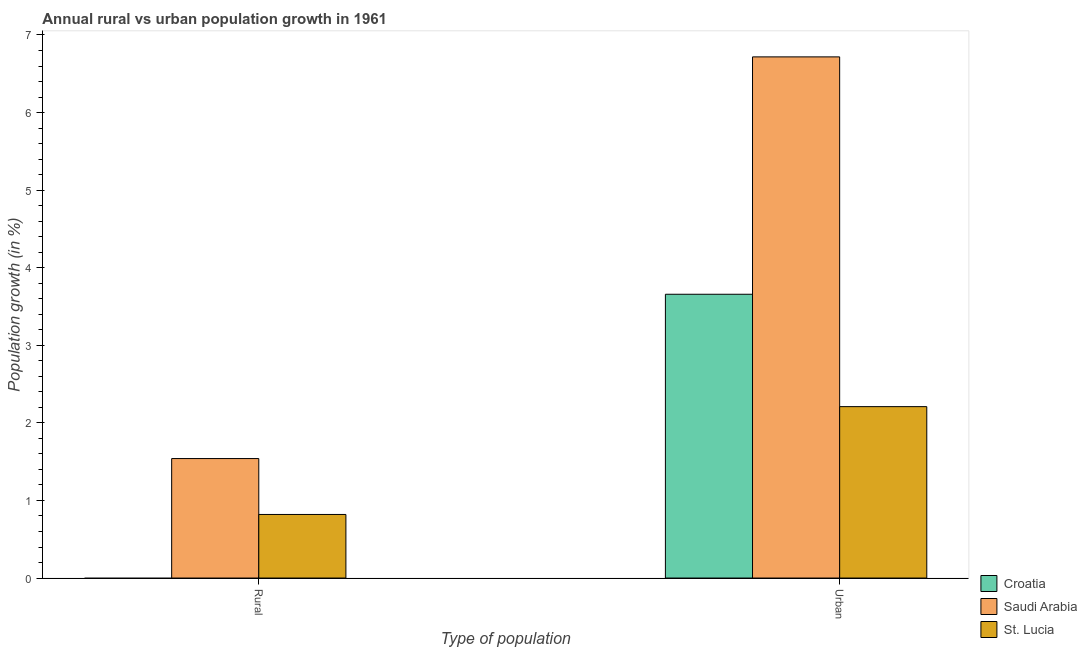How many different coloured bars are there?
Ensure brevity in your answer.  3. Are the number of bars per tick equal to the number of legend labels?
Offer a terse response. No. Are the number of bars on each tick of the X-axis equal?
Your response must be concise. No. What is the label of the 2nd group of bars from the left?
Your response must be concise. Urban . What is the rural population growth in Saudi Arabia?
Provide a succinct answer. 1.54. Across all countries, what is the maximum rural population growth?
Offer a very short reply. 1.54. Across all countries, what is the minimum urban population growth?
Keep it short and to the point. 2.21. In which country was the urban population growth maximum?
Offer a very short reply. Saudi Arabia. What is the total rural population growth in the graph?
Provide a short and direct response. 2.36. What is the difference between the urban population growth in Saudi Arabia and that in Croatia?
Keep it short and to the point. 3.06. What is the difference between the urban population growth in Croatia and the rural population growth in St. Lucia?
Make the answer very short. 2.84. What is the average urban population growth per country?
Offer a terse response. 4.2. What is the difference between the rural population growth and urban population growth in St. Lucia?
Provide a succinct answer. -1.39. What is the ratio of the urban population growth in St. Lucia to that in Croatia?
Your answer should be compact. 0.6. Is the urban population growth in Croatia less than that in St. Lucia?
Your answer should be compact. No. In how many countries, is the urban population growth greater than the average urban population growth taken over all countries?
Offer a very short reply. 1. How many countries are there in the graph?
Make the answer very short. 3. Does the graph contain any zero values?
Your response must be concise. Yes. Does the graph contain grids?
Your response must be concise. No. Where does the legend appear in the graph?
Your answer should be compact. Bottom right. How many legend labels are there?
Offer a very short reply. 3. How are the legend labels stacked?
Offer a very short reply. Vertical. What is the title of the graph?
Offer a terse response. Annual rural vs urban population growth in 1961. Does "Small states" appear as one of the legend labels in the graph?
Provide a short and direct response. No. What is the label or title of the X-axis?
Your answer should be compact. Type of population. What is the label or title of the Y-axis?
Provide a short and direct response. Population growth (in %). What is the Population growth (in %) of Croatia in Rural?
Provide a short and direct response. 0. What is the Population growth (in %) of Saudi Arabia in Rural?
Ensure brevity in your answer.  1.54. What is the Population growth (in %) in St. Lucia in Rural?
Your answer should be very brief. 0.82. What is the Population growth (in %) in Croatia in Urban ?
Keep it short and to the point. 3.66. What is the Population growth (in %) in Saudi Arabia in Urban ?
Make the answer very short. 6.72. What is the Population growth (in %) in St. Lucia in Urban ?
Your response must be concise. 2.21. Across all Type of population, what is the maximum Population growth (in %) of Croatia?
Offer a terse response. 3.66. Across all Type of population, what is the maximum Population growth (in %) in Saudi Arabia?
Provide a succinct answer. 6.72. Across all Type of population, what is the maximum Population growth (in %) in St. Lucia?
Offer a very short reply. 2.21. Across all Type of population, what is the minimum Population growth (in %) of Croatia?
Ensure brevity in your answer.  0. Across all Type of population, what is the minimum Population growth (in %) in Saudi Arabia?
Offer a very short reply. 1.54. Across all Type of population, what is the minimum Population growth (in %) of St. Lucia?
Provide a short and direct response. 0.82. What is the total Population growth (in %) in Croatia in the graph?
Your response must be concise. 3.66. What is the total Population growth (in %) of Saudi Arabia in the graph?
Offer a terse response. 8.26. What is the total Population growth (in %) in St. Lucia in the graph?
Provide a succinct answer. 3.03. What is the difference between the Population growth (in %) in Saudi Arabia in Rural and that in Urban ?
Give a very brief answer. -5.18. What is the difference between the Population growth (in %) in St. Lucia in Rural and that in Urban ?
Your response must be concise. -1.39. What is the difference between the Population growth (in %) in Saudi Arabia in Rural and the Population growth (in %) in St. Lucia in Urban?
Make the answer very short. -0.67. What is the average Population growth (in %) in Croatia per Type of population?
Provide a succinct answer. 1.83. What is the average Population growth (in %) in Saudi Arabia per Type of population?
Your response must be concise. 4.13. What is the average Population growth (in %) in St. Lucia per Type of population?
Keep it short and to the point. 1.51. What is the difference between the Population growth (in %) in Saudi Arabia and Population growth (in %) in St. Lucia in Rural?
Keep it short and to the point. 0.72. What is the difference between the Population growth (in %) of Croatia and Population growth (in %) of Saudi Arabia in Urban ?
Offer a very short reply. -3.06. What is the difference between the Population growth (in %) in Croatia and Population growth (in %) in St. Lucia in Urban ?
Make the answer very short. 1.45. What is the difference between the Population growth (in %) of Saudi Arabia and Population growth (in %) of St. Lucia in Urban ?
Your answer should be compact. 4.51. What is the ratio of the Population growth (in %) of Saudi Arabia in Rural to that in Urban ?
Make the answer very short. 0.23. What is the ratio of the Population growth (in %) in St. Lucia in Rural to that in Urban ?
Make the answer very short. 0.37. What is the difference between the highest and the second highest Population growth (in %) of Saudi Arabia?
Ensure brevity in your answer.  5.18. What is the difference between the highest and the second highest Population growth (in %) in St. Lucia?
Give a very brief answer. 1.39. What is the difference between the highest and the lowest Population growth (in %) of Croatia?
Offer a terse response. 3.66. What is the difference between the highest and the lowest Population growth (in %) of Saudi Arabia?
Keep it short and to the point. 5.18. What is the difference between the highest and the lowest Population growth (in %) of St. Lucia?
Provide a succinct answer. 1.39. 